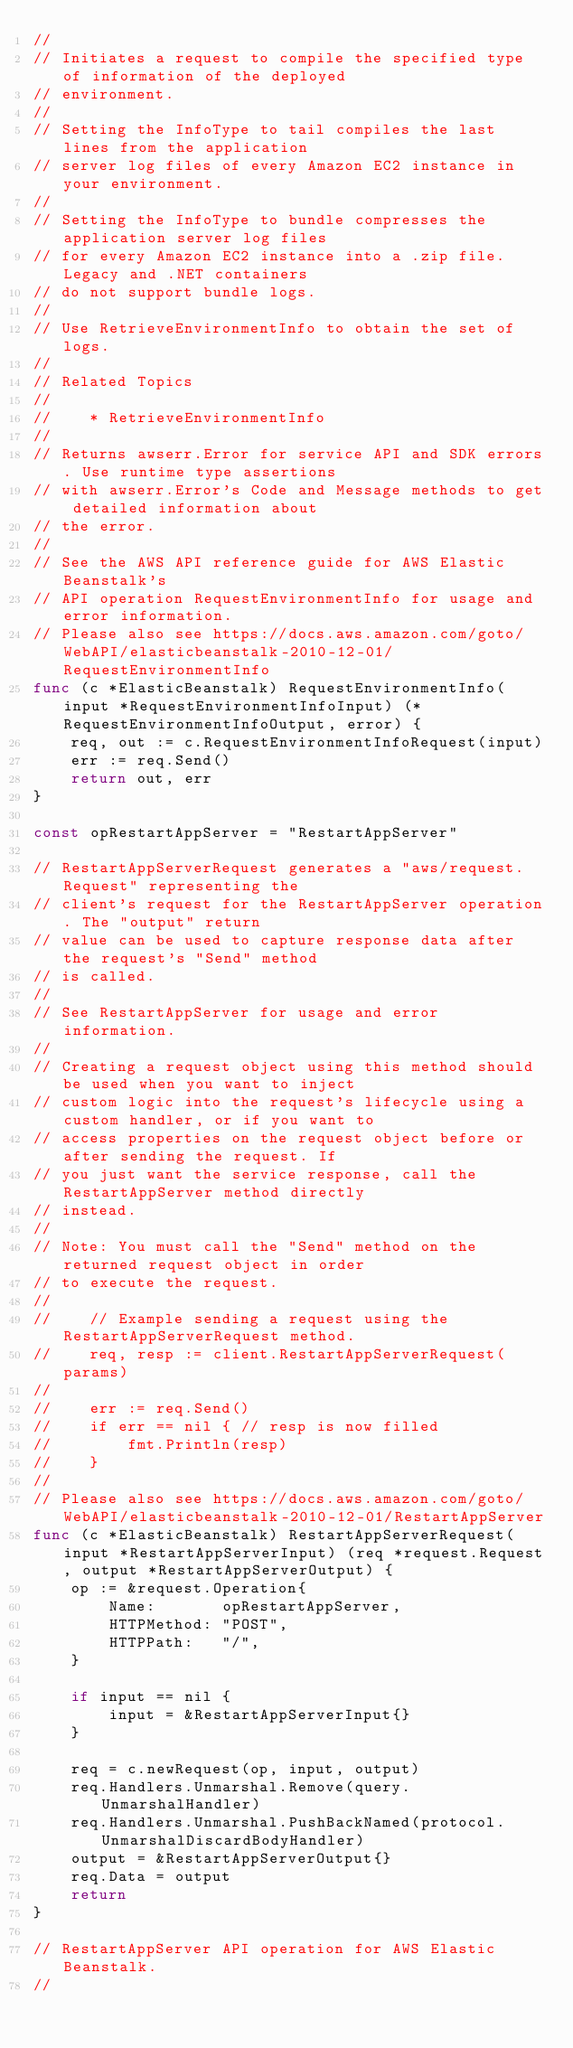<code> <loc_0><loc_0><loc_500><loc_500><_Go_>//
// Initiates a request to compile the specified type of information of the deployed
// environment.
//
// Setting the InfoType to tail compiles the last lines from the application
// server log files of every Amazon EC2 instance in your environment.
//
// Setting the InfoType to bundle compresses the application server log files
// for every Amazon EC2 instance into a .zip file. Legacy and .NET containers
// do not support bundle logs.
//
// Use RetrieveEnvironmentInfo to obtain the set of logs.
//
// Related Topics
//
//    * RetrieveEnvironmentInfo
//
// Returns awserr.Error for service API and SDK errors. Use runtime type assertions
// with awserr.Error's Code and Message methods to get detailed information about
// the error.
//
// See the AWS API reference guide for AWS Elastic Beanstalk's
// API operation RequestEnvironmentInfo for usage and error information.
// Please also see https://docs.aws.amazon.com/goto/WebAPI/elasticbeanstalk-2010-12-01/RequestEnvironmentInfo
func (c *ElasticBeanstalk) RequestEnvironmentInfo(input *RequestEnvironmentInfoInput) (*RequestEnvironmentInfoOutput, error) {
	req, out := c.RequestEnvironmentInfoRequest(input)
	err := req.Send()
	return out, err
}

const opRestartAppServer = "RestartAppServer"

// RestartAppServerRequest generates a "aws/request.Request" representing the
// client's request for the RestartAppServer operation. The "output" return
// value can be used to capture response data after the request's "Send" method
// is called.
//
// See RestartAppServer for usage and error information.
//
// Creating a request object using this method should be used when you want to inject
// custom logic into the request's lifecycle using a custom handler, or if you want to
// access properties on the request object before or after sending the request. If
// you just want the service response, call the RestartAppServer method directly
// instead.
//
// Note: You must call the "Send" method on the returned request object in order
// to execute the request.
//
//    // Example sending a request using the RestartAppServerRequest method.
//    req, resp := client.RestartAppServerRequest(params)
//
//    err := req.Send()
//    if err == nil { // resp is now filled
//        fmt.Println(resp)
//    }
//
// Please also see https://docs.aws.amazon.com/goto/WebAPI/elasticbeanstalk-2010-12-01/RestartAppServer
func (c *ElasticBeanstalk) RestartAppServerRequest(input *RestartAppServerInput) (req *request.Request, output *RestartAppServerOutput) {
	op := &request.Operation{
		Name:       opRestartAppServer,
		HTTPMethod: "POST",
		HTTPPath:   "/",
	}

	if input == nil {
		input = &RestartAppServerInput{}
	}

	req = c.newRequest(op, input, output)
	req.Handlers.Unmarshal.Remove(query.UnmarshalHandler)
	req.Handlers.Unmarshal.PushBackNamed(protocol.UnmarshalDiscardBodyHandler)
	output = &RestartAppServerOutput{}
	req.Data = output
	return
}

// RestartAppServer API operation for AWS Elastic Beanstalk.
//</code> 